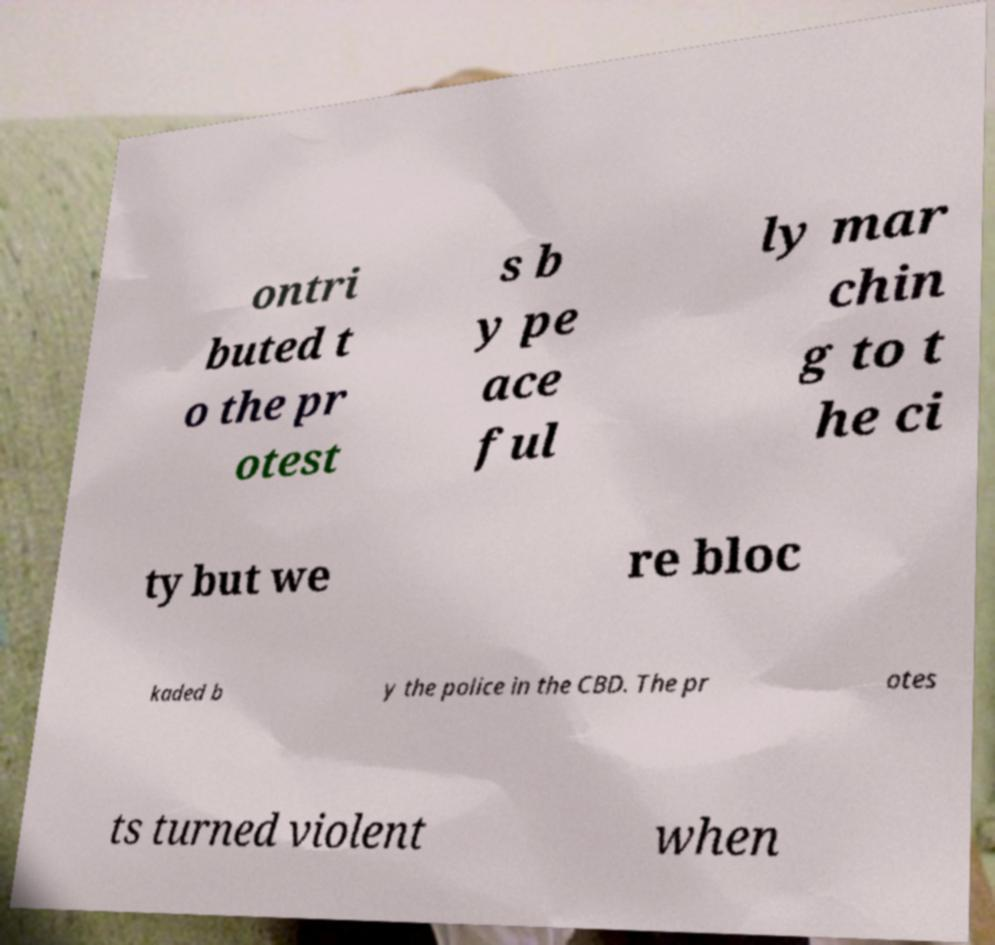Can you accurately transcribe the text from the provided image for me? ontri buted t o the pr otest s b y pe ace ful ly mar chin g to t he ci ty but we re bloc kaded b y the police in the CBD. The pr otes ts turned violent when 